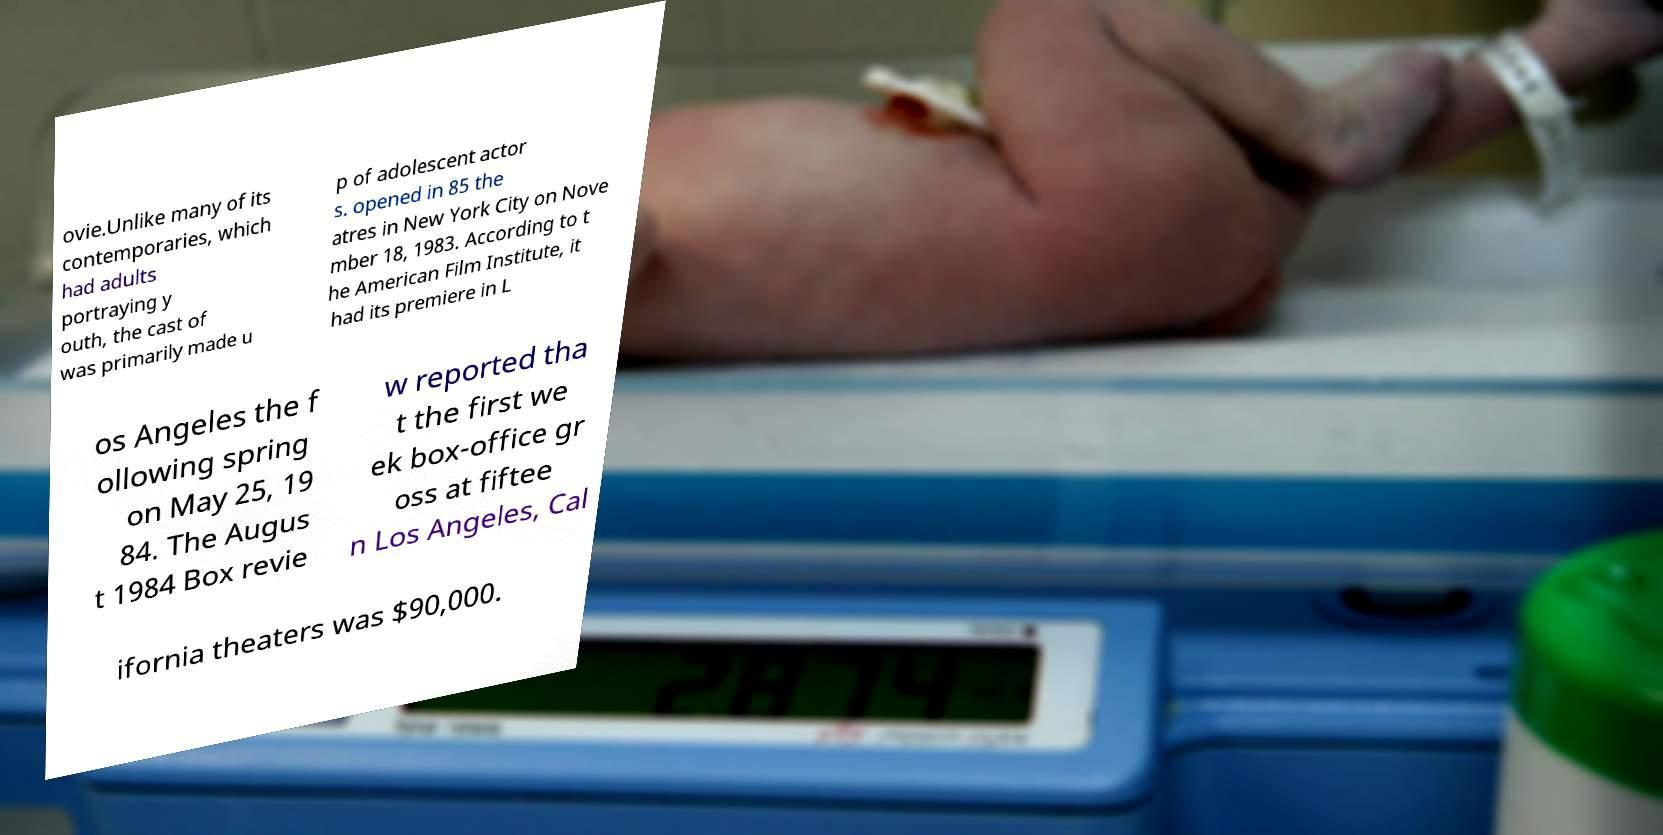Can you read and provide the text displayed in the image?This photo seems to have some interesting text. Can you extract and type it out for me? ovie.Unlike many of its contemporaries, which had adults portraying y outh, the cast of was primarily made u p of adolescent actor s. opened in 85 the atres in New York City on Nove mber 18, 1983. According to t he American Film Institute, it had its premiere in L os Angeles the f ollowing spring on May 25, 19 84. The Augus t 1984 Box revie w reported tha t the first we ek box-office gr oss at fiftee n Los Angeles, Cal ifornia theaters was $90,000. 